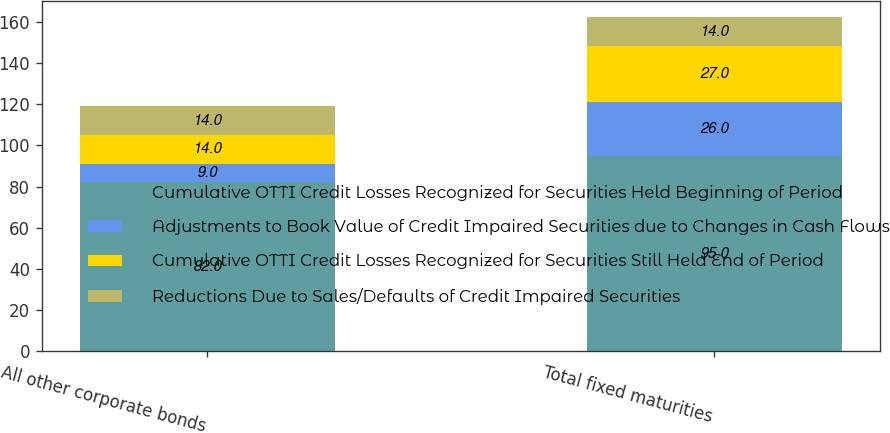Convert chart to OTSL. <chart><loc_0><loc_0><loc_500><loc_500><stacked_bar_chart><ecel><fcel>All other corporate bonds<fcel>Total fixed maturities<nl><fcel>Cumulative OTTI Credit Losses Recognized for Securities Held Beginning of Period<fcel>82<fcel>95<nl><fcel>Adjustments to Book Value of Credit Impaired Securities due to Changes in Cash Flows<fcel>9<fcel>26<nl><fcel>Cumulative OTTI Credit Losses Recognized for Securities Still Held End of Period<fcel>14<fcel>27<nl><fcel>Reductions Due to Sales/Defaults of Credit Impaired Securities<fcel>14<fcel>14<nl></chart> 